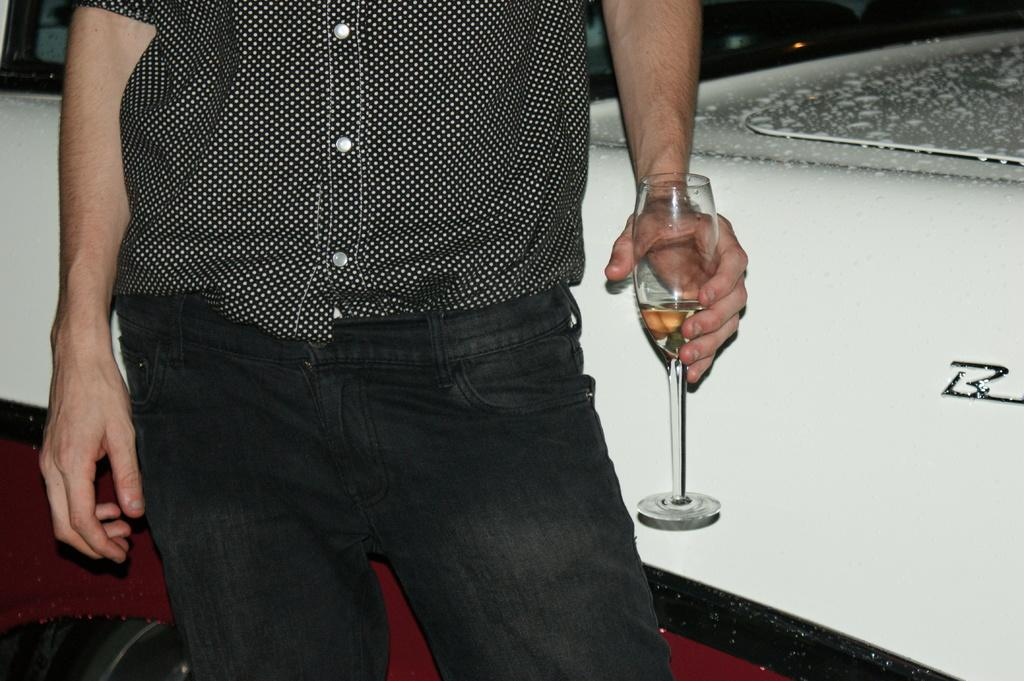Who is present in the image? There is a man in the image. What is the man holding in the image? The man is holding a glass in the image. What is in the glass that the man is holding? The glass contains wine. What type of stove is visible in the image? There is no stove present in the image. 